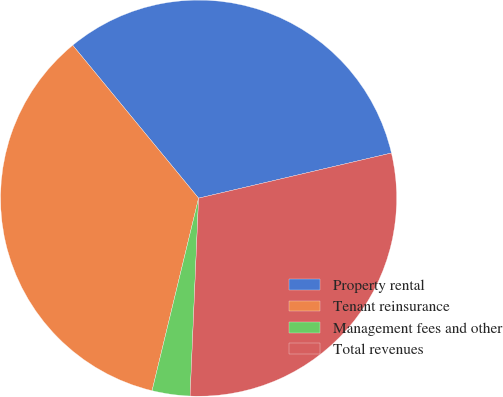<chart> <loc_0><loc_0><loc_500><loc_500><pie_chart><fcel>Property rental<fcel>Tenant reinsurance<fcel>Management fees and other<fcel>Total revenues<nl><fcel>32.3%<fcel>35.26%<fcel>3.09%<fcel>29.34%<nl></chart> 